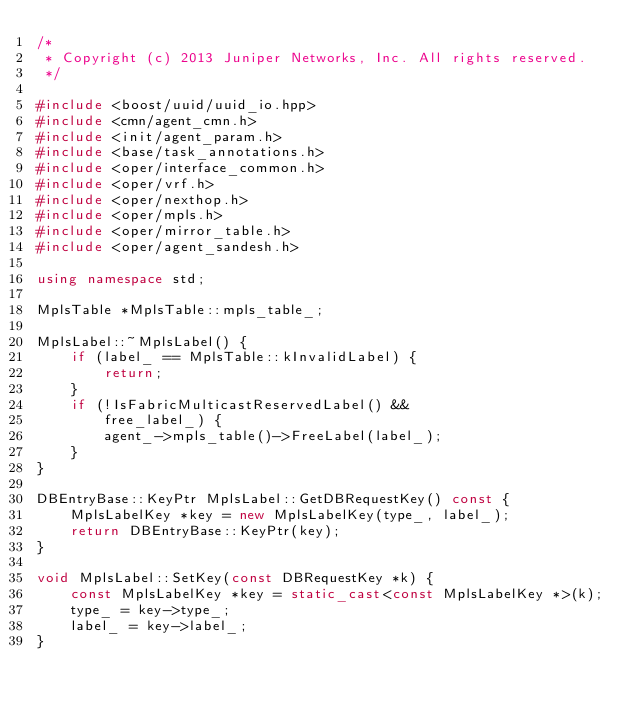Convert code to text. <code><loc_0><loc_0><loc_500><loc_500><_C++_>/*
 * Copyright (c) 2013 Juniper Networks, Inc. All rights reserved.
 */

#include <boost/uuid/uuid_io.hpp>
#include <cmn/agent_cmn.h>
#include <init/agent_param.h>
#include <base/task_annotations.h>
#include <oper/interface_common.h>
#include <oper/vrf.h>
#include <oper/nexthop.h>
#include <oper/mpls.h>
#include <oper/mirror_table.h>
#include <oper/agent_sandesh.h>

using namespace std;

MplsTable *MplsTable::mpls_table_;

MplsLabel::~MplsLabel() { 
    if (label_ == MplsTable::kInvalidLabel) {
        return;
    }
    if (!IsFabricMulticastReservedLabel() &&
        free_label_) {
        agent_->mpls_table()->FreeLabel(label_);
    }
}

DBEntryBase::KeyPtr MplsLabel::GetDBRequestKey() const {
    MplsLabelKey *key = new MplsLabelKey(type_, label_);
    return DBEntryBase::KeyPtr(key);
}

void MplsLabel::SetKey(const DBRequestKey *k) { 
    const MplsLabelKey *key = static_cast<const MplsLabelKey *>(k);
    type_ = key->type_;
    label_ = key->label_;
}
</code> 